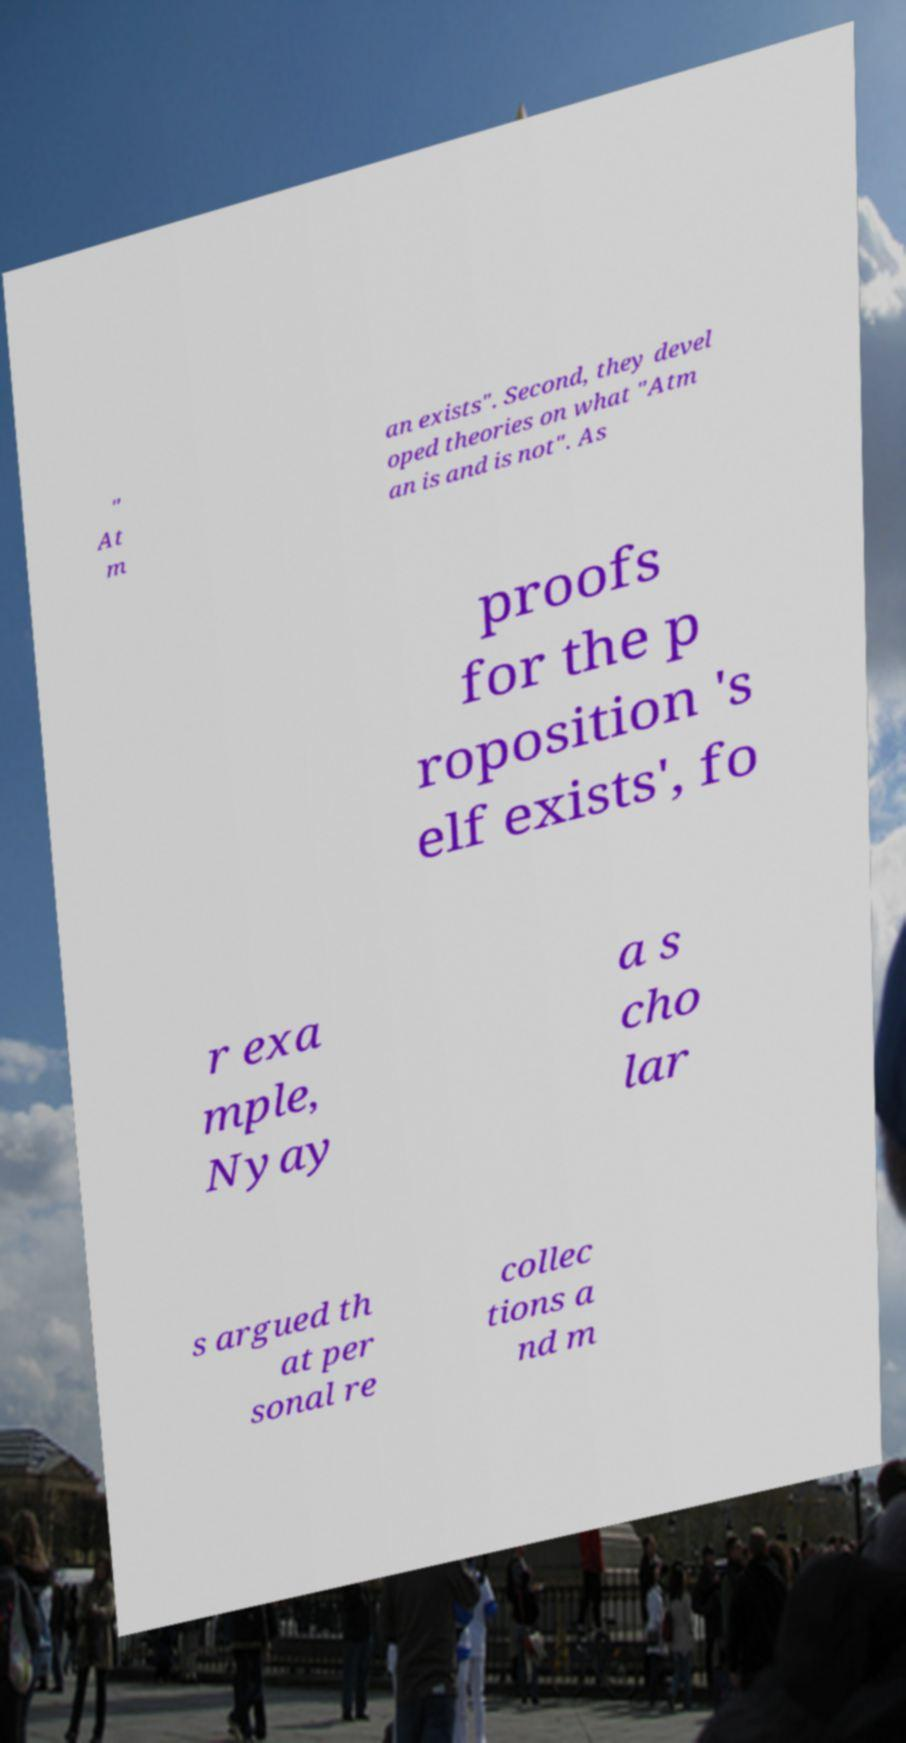Can you read and provide the text displayed in the image?This photo seems to have some interesting text. Can you extract and type it out for me? " At m an exists". Second, they devel oped theories on what "Atm an is and is not". As proofs for the p roposition 's elf exists', fo r exa mple, Nyay a s cho lar s argued th at per sonal re collec tions a nd m 